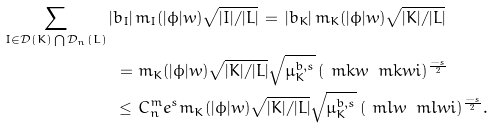Convert formula to latex. <formula><loc_0><loc_0><loc_500><loc_500>\sum _ { I \in \mathcal { D } ( K ) \bigcap \mathcal { D } _ { n } ( L ) } | b _ { I } | \, & m _ { I } ( | \phi | w ) { \sqrt { | I | / | L | } } \, = \, { | b _ { K } | } \, m _ { K } ( | \phi | w ) { \sqrt { | K | / | L | } } \\ = \, & \, m _ { K } ( | \phi | w ) \sqrt { | K | / | L | } \sqrt { \mu ^ { b , s } _ { K } } \, ( \ m k w \, \ m k w i ) ^ { \frac { - s } { 2 } } \\ \leq \, & \, C ^ { m } _ { n } e ^ { s } m _ { K } ( | \phi | w ) \sqrt { | K | / | L | } \sqrt { \mu ^ { b , s } _ { K } } \, ( \ m l w \, \ m l w i ) ^ { \frac { - s } { 2 } } .</formula> 